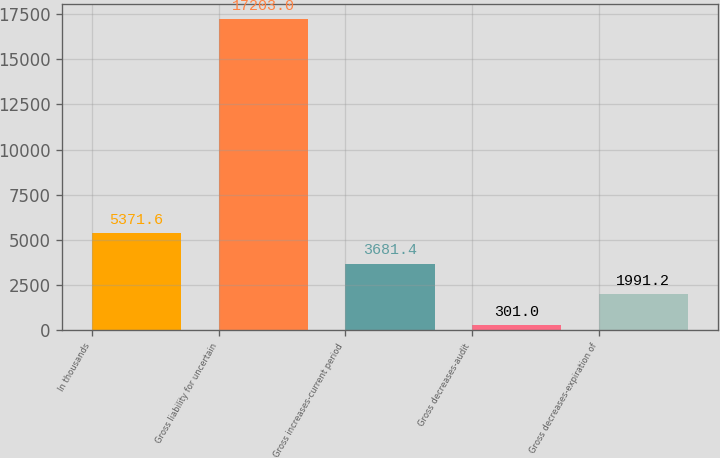Convert chart. <chart><loc_0><loc_0><loc_500><loc_500><bar_chart><fcel>In thousands<fcel>Gross liability for uncertain<fcel>Gross increases-current period<fcel>Gross decreases-audit<fcel>Gross decreases-expiration of<nl><fcel>5371.6<fcel>17203<fcel>3681.4<fcel>301<fcel>1991.2<nl></chart> 